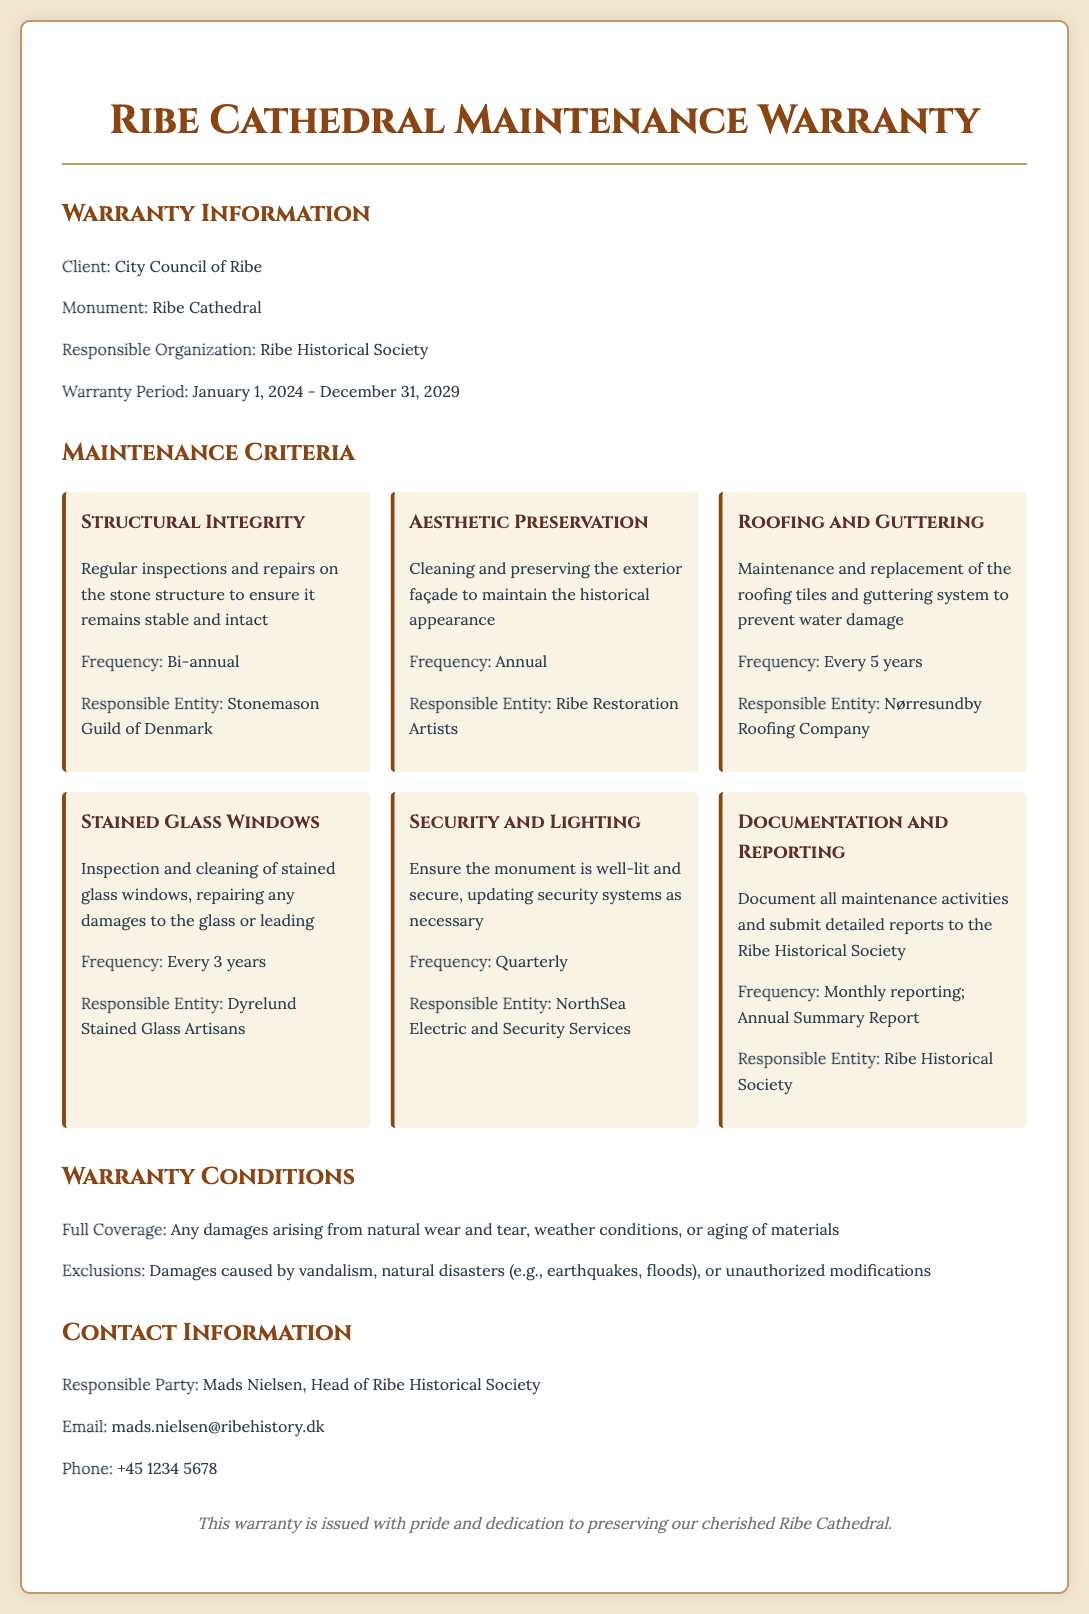What is the responsible organization for Ribe Cathedral? The document states that the responsible organization is the Ribe Historical Society.
Answer: Ribe Historical Society What is the warranty period for the maintenance? The document specifies the warranty period as January 1, 2024 - December 31, 2029.
Answer: January 1, 2024 - December 31, 2029 How often will the structural integrity be inspected? The frequency of inspections for structural integrity is mentioned as bi-annual in the document.
Answer: Bi-annual Who is responsible for the aesthetic preservation? The document lists the Ribe Restoration Artists as the responsible entity for aesthetic preservation.
Answer: Ribe Restoration Artists What is excluded from the warranty coverage? The document states that damages caused by vandalism, natural disasters, or unauthorized modifications are excluded from coverage.
Answer: Vandalism, natural disasters, unauthorized modifications What is the frequency of documentation and reporting? It is indicated that reporting should occur monthly with an annual summary report in the document.
Answer: Monthly reporting; Annual Summary Report Who should be contacted regarding the warranty? The document mentions Mads Nielsen as the responsible party to contact.
Answer: Mads Nielsen What is the email address for the responsible party? The document lists the email address as mads.nielsen@ribehistory.dk.
Answer: mads.nielsen@ribehistory.dk 